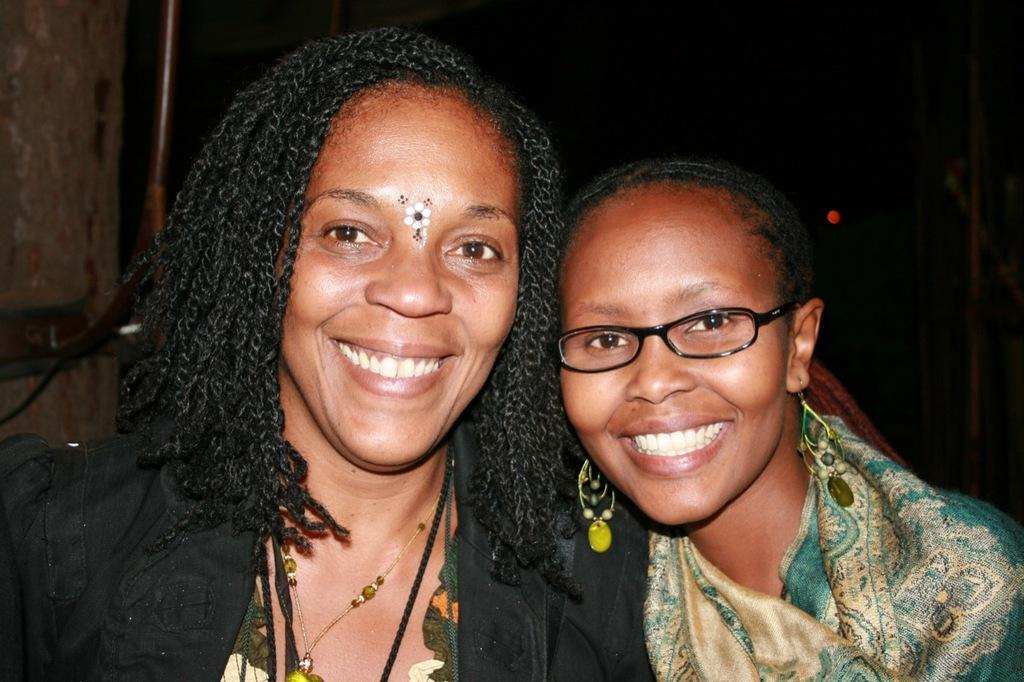How many people are in the image? There are two women in the image. What is one of the women wearing? One of the women is wearing spectacles. What expression do both women have? Both women are smiling. What can be observed about the background of the image? The background of the image is dark. What color is the crayon being used by the women in the image? There is no crayon present in the image. How many feet can be seen in the image? The image does not show any feet; it only shows two women from the waist up. 